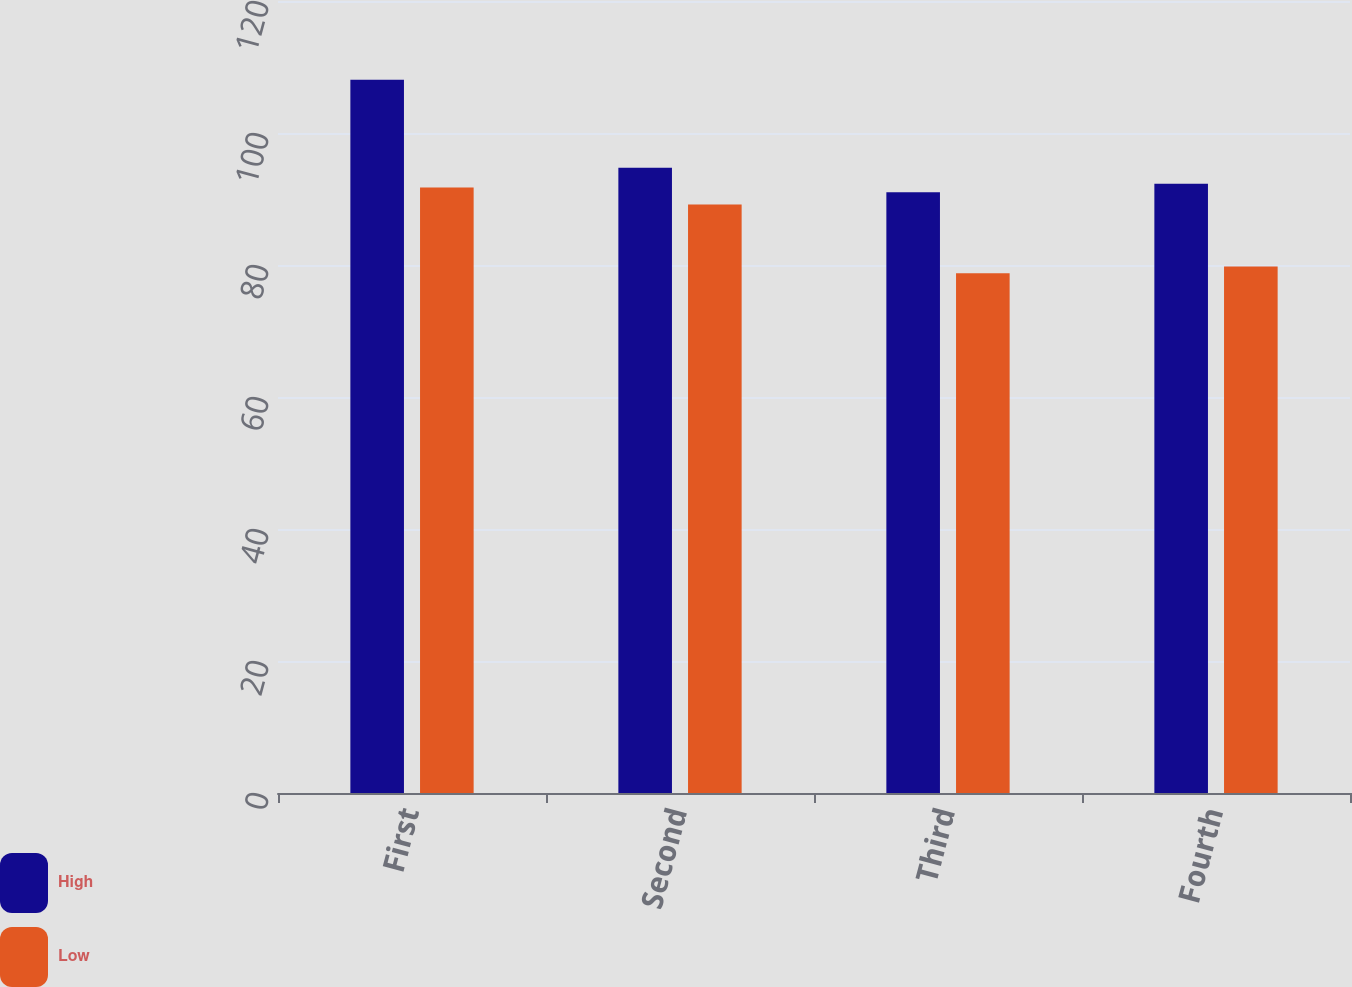Convert chart to OTSL. <chart><loc_0><loc_0><loc_500><loc_500><stacked_bar_chart><ecel><fcel>First<fcel>Second<fcel>Third<fcel>Fourth<nl><fcel>High<fcel>108.07<fcel>94.74<fcel>91.02<fcel>92.32<nl><fcel>Low<fcel>91.74<fcel>89.17<fcel>78.76<fcel>79.77<nl></chart> 